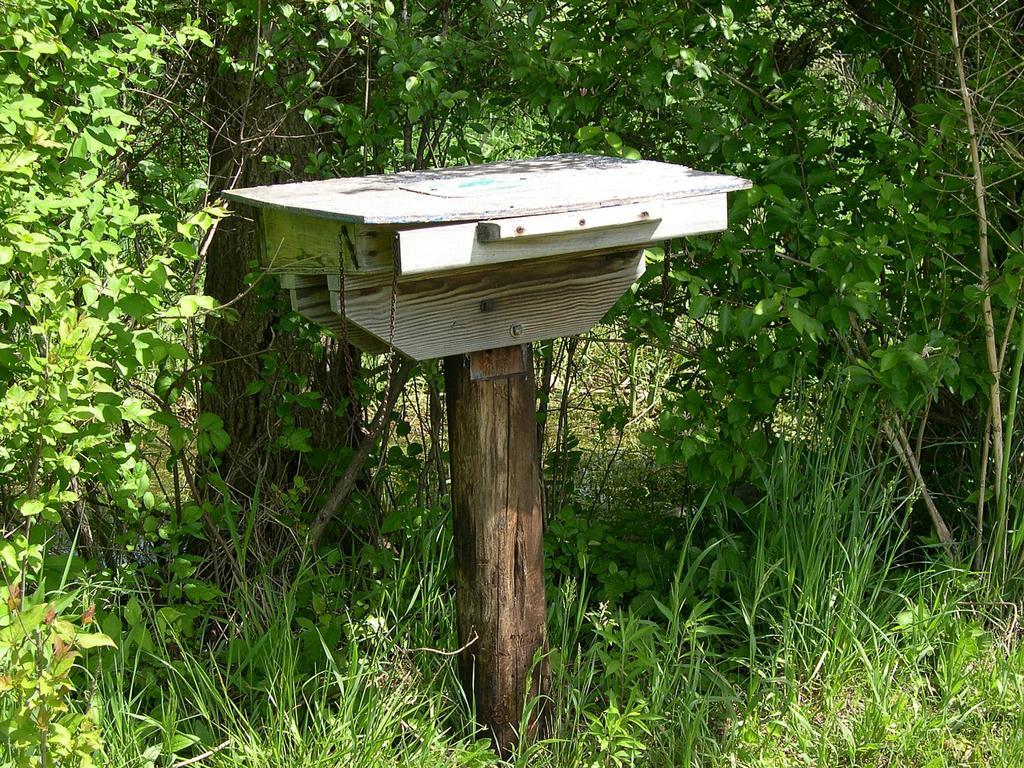Describe this image in one or two sentences. In this image I can see few trees, grass and the white color object is on the wooden pole. 